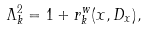Convert formula to latex. <formula><loc_0><loc_0><loc_500><loc_500>\Lambda _ { k } ^ { 2 } = 1 + r _ { k } ^ { w } ( x , D _ { x } ) ,</formula> 